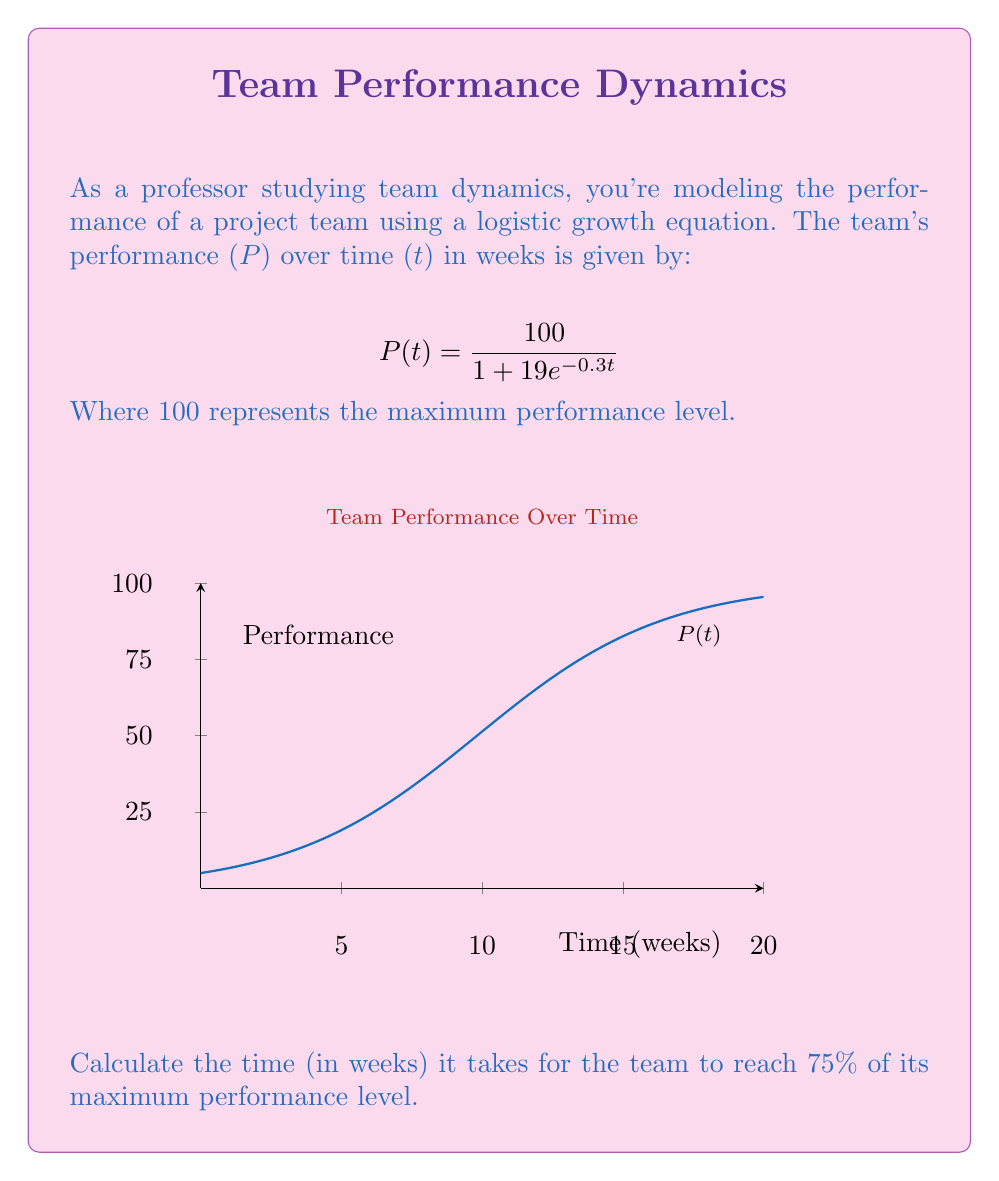Teach me how to tackle this problem. To solve this problem, we'll follow these steps:

1) We need to find t when P(t) = 75% of the maximum performance (100).
   So, we're looking for P(t) = 75.

2) Set up the equation:
   $$75 = \frac{100}{1 + 19e^{-0.3t}}$$

3) Multiply both sides by $(1 + 19e^{-0.3t})$:
   $$75(1 + 19e^{-0.3t}) = 100$$

4) Distribute on the left side:
   $$75 + 1425e^{-0.3t} = 100$$

5) Subtract 75 from both sides:
   $$1425e^{-0.3t} = 25$$

6) Divide both sides by 1425:
   $$e^{-0.3t} = \frac{25}{1425} = \frac{1}{57}$$

7) Take the natural log of both sides:
   $$-0.3t = \ln(\frac{1}{57})$$

8) Divide both sides by -0.3:
   $$t = -\frac{\ln(\frac{1}{57})}{0.3}$$

9) Calculate:
   $$t = -\frac{\ln(0.0175)}{0.3} \approx 13.46$$

Therefore, it takes approximately 13.46 weeks for the team to reach 75% of its maximum performance level.
Answer: 13.46 weeks 